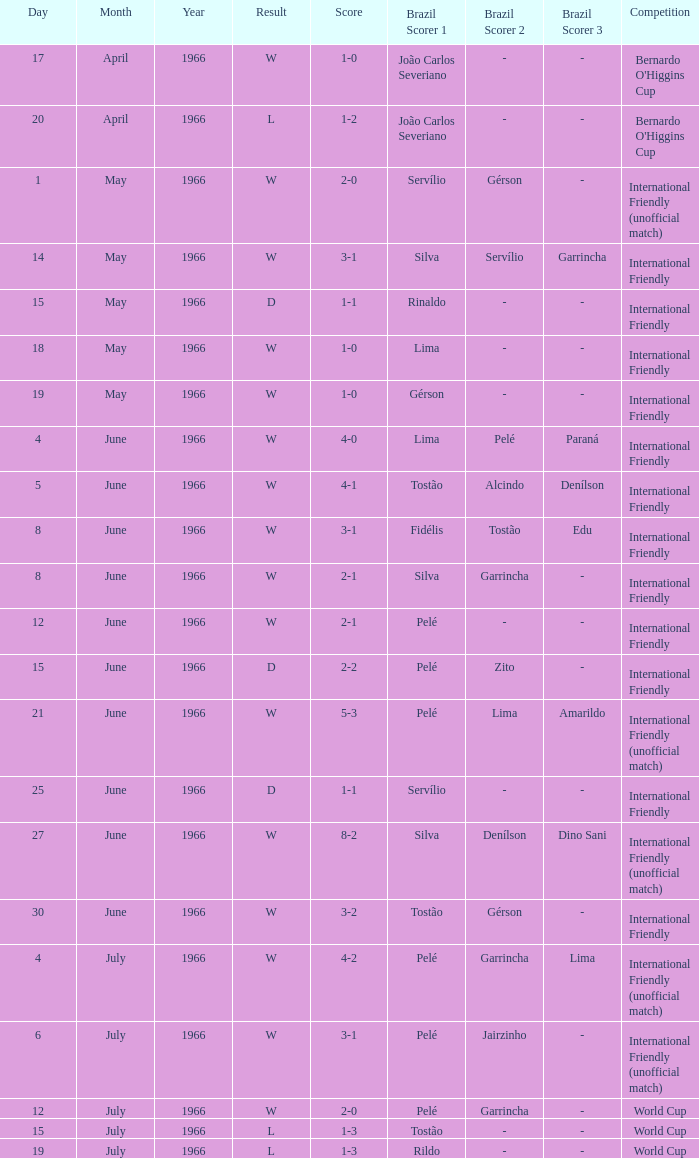What is the result when the score is 4-0? W. 